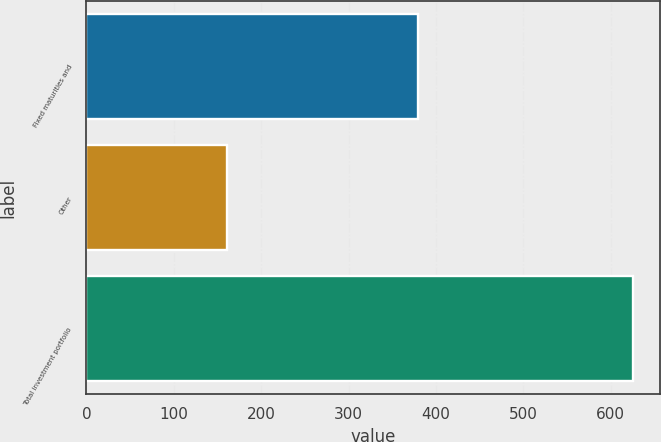Convert chart. <chart><loc_0><loc_0><loc_500><loc_500><bar_chart><fcel>Fixed maturities and<fcel>Other<fcel>Total investment portfolio<nl><fcel>380<fcel>161<fcel>625<nl></chart> 